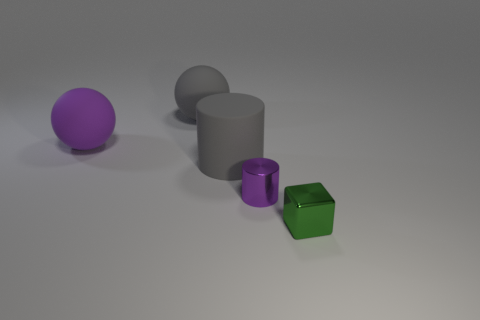Add 2 purple balls. How many objects exist? 7 Subtract all spheres. How many objects are left? 3 Subtract 0 yellow blocks. How many objects are left? 5 Subtract all gray cylinders. Subtract all metallic cylinders. How many objects are left? 3 Add 2 small metal objects. How many small metal objects are left? 4 Add 4 cubes. How many cubes exist? 5 